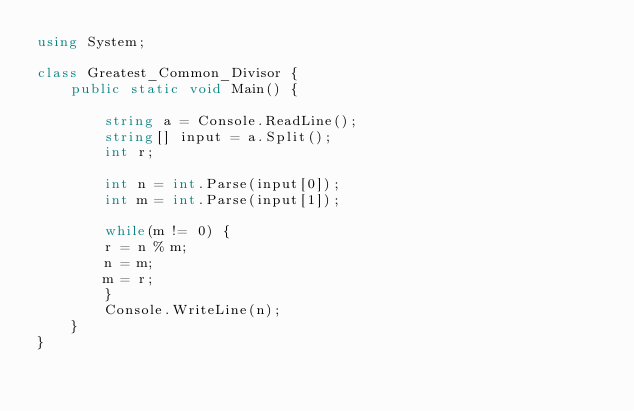<code> <loc_0><loc_0><loc_500><loc_500><_C#_>using System;

class Greatest_Common_Divisor {
	public static void Main() {

		string a = Console.ReadLine();
		string[] input = a.Split();
		int r;

		int n = int.Parse(input[0]);
		int m = int.Parse(input[1]);

		while(m != 0) {
		r = n % m;
		n = m;
		m = r;	
		}
		Console.WriteLine(n);
	}
}</code> 